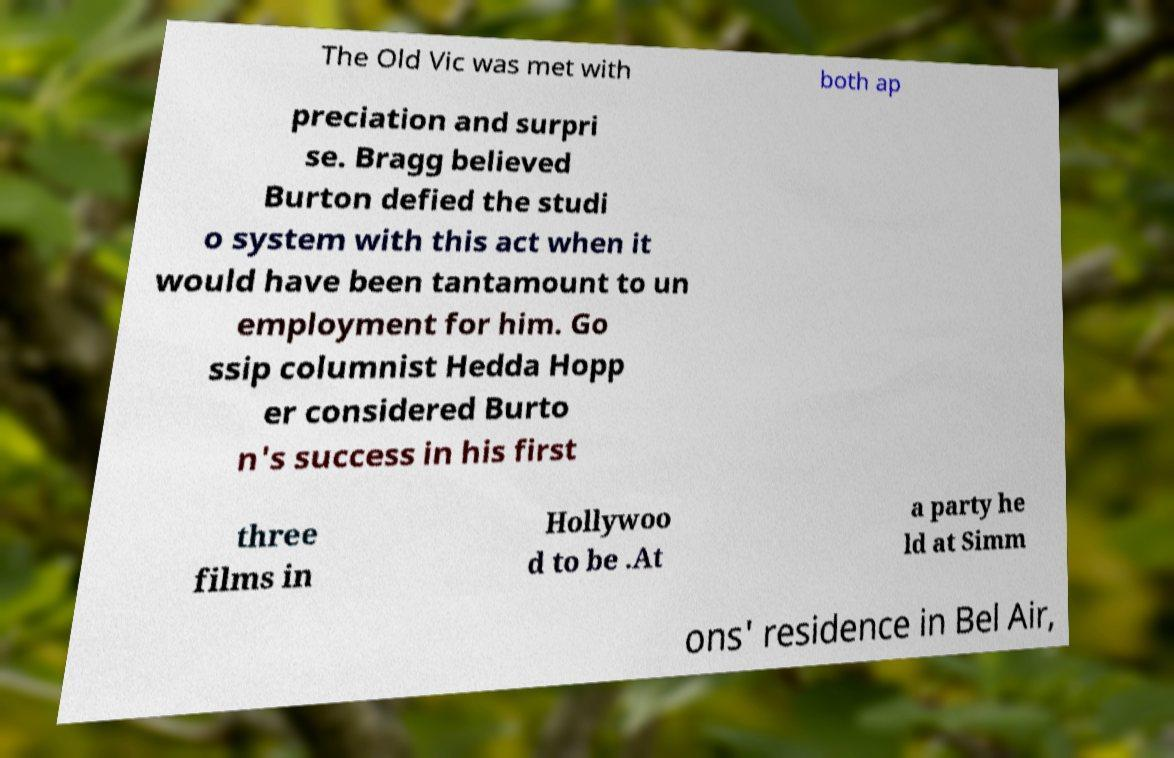For documentation purposes, I need the text within this image transcribed. Could you provide that? The Old Vic was met with both ap preciation and surpri se. Bragg believed Burton defied the studi o system with this act when it would have been tantamount to un employment for him. Go ssip columnist Hedda Hopp er considered Burto n's success in his first three films in Hollywoo d to be .At a party he ld at Simm ons' residence in Bel Air, 